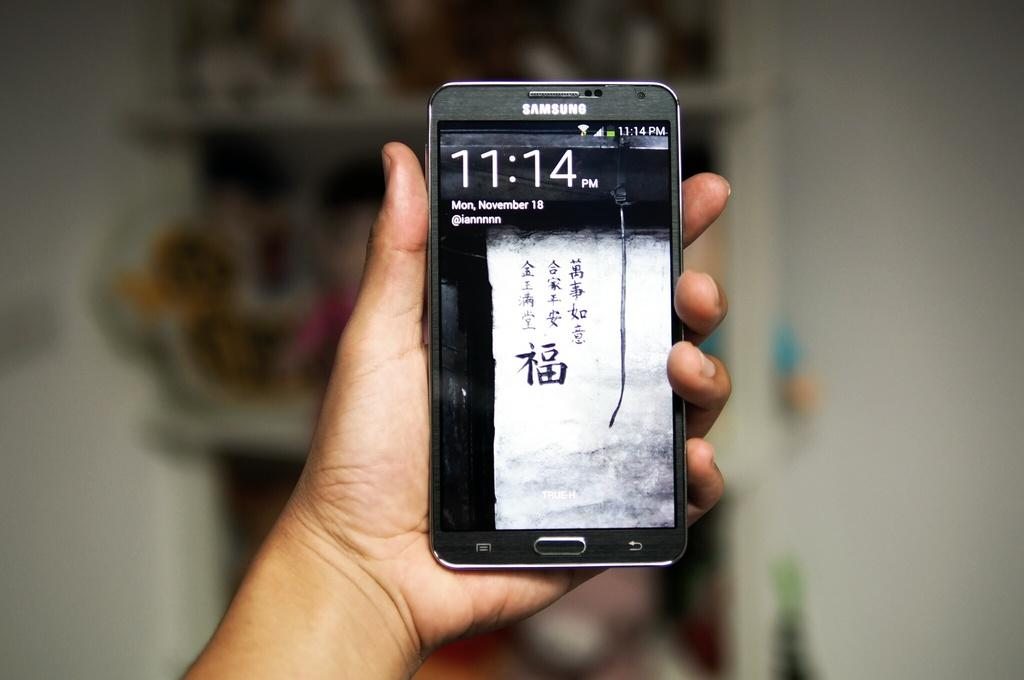<image>
Summarize the visual content of the image. A samsung phone with a crack down it reading 11.14 Monday November 18 